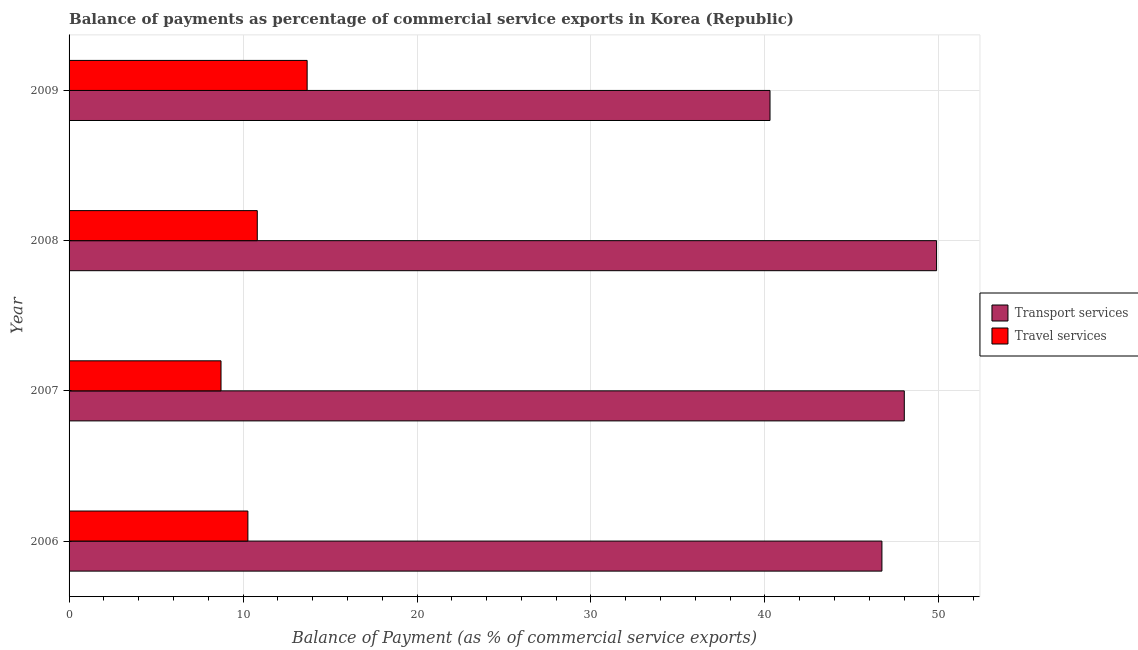How many different coloured bars are there?
Offer a terse response. 2. How many groups of bars are there?
Your response must be concise. 4. How many bars are there on the 1st tick from the bottom?
Make the answer very short. 2. What is the balance of payments of transport services in 2007?
Keep it short and to the point. 48.01. Across all years, what is the maximum balance of payments of transport services?
Keep it short and to the point. 49.86. Across all years, what is the minimum balance of payments of transport services?
Ensure brevity in your answer.  40.29. In which year was the balance of payments of transport services minimum?
Provide a short and direct response. 2009. What is the total balance of payments of travel services in the graph?
Keep it short and to the point. 43.52. What is the difference between the balance of payments of transport services in 2008 and that in 2009?
Keep it short and to the point. 9.57. What is the difference between the balance of payments of transport services in 2008 and the balance of payments of travel services in 2009?
Your response must be concise. 36.18. What is the average balance of payments of travel services per year?
Give a very brief answer. 10.88. In the year 2007, what is the difference between the balance of payments of transport services and balance of payments of travel services?
Keep it short and to the point. 39.28. What is the ratio of the balance of payments of travel services in 2008 to that in 2009?
Keep it short and to the point. 0.79. What is the difference between the highest and the second highest balance of payments of transport services?
Your answer should be compact. 1.85. What is the difference between the highest and the lowest balance of payments of travel services?
Make the answer very short. 4.95. Is the sum of the balance of payments of transport services in 2006 and 2008 greater than the maximum balance of payments of travel services across all years?
Make the answer very short. Yes. What does the 1st bar from the top in 2007 represents?
Your answer should be compact. Travel services. What does the 2nd bar from the bottom in 2007 represents?
Your response must be concise. Travel services. How many bars are there?
Provide a succinct answer. 8. Are all the bars in the graph horizontal?
Your answer should be compact. Yes. What is the difference between two consecutive major ticks on the X-axis?
Make the answer very short. 10. Are the values on the major ticks of X-axis written in scientific E-notation?
Offer a very short reply. No. Where does the legend appear in the graph?
Your response must be concise. Center right. How many legend labels are there?
Ensure brevity in your answer.  2. How are the legend labels stacked?
Offer a terse response. Vertical. What is the title of the graph?
Ensure brevity in your answer.  Balance of payments as percentage of commercial service exports in Korea (Republic). Does "Current US$" appear as one of the legend labels in the graph?
Your answer should be very brief. No. What is the label or title of the X-axis?
Provide a succinct answer. Balance of Payment (as % of commercial service exports). What is the Balance of Payment (as % of commercial service exports) in Transport services in 2006?
Your answer should be very brief. 46.72. What is the Balance of Payment (as % of commercial service exports) in Travel services in 2006?
Your response must be concise. 10.28. What is the Balance of Payment (as % of commercial service exports) of Transport services in 2007?
Offer a very short reply. 48.01. What is the Balance of Payment (as % of commercial service exports) in Travel services in 2007?
Make the answer very short. 8.73. What is the Balance of Payment (as % of commercial service exports) in Transport services in 2008?
Provide a short and direct response. 49.86. What is the Balance of Payment (as % of commercial service exports) of Travel services in 2008?
Keep it short and to the point. 10.82. What is the Balance of Payment (as % of commercial service exports) of Transport services in 2009?
Provide a short and direct response. 40.29. What is the Balance of Payment (as % of commercial service exports) in Travel services in 2009?
Your response must be concise. 13.68. Across all years, what is the maximum Balance of Payment (as % of commercial service exports) in Transport services?
Give a very brief answer. 49.86. Across all years, what is the maximum Balance of Payment (as % of commercial service exports) of Travel services?
Give a very brief answer. 13.68. Across all years, what is the minimum Balance of Payment (as % of commercial service exports) of Transport services?
Your answer should be very brief. 40.29. Across all years, what is the minimum Balance of Payment (as % of commercial service exports) of Travel services?
Provide a succinct answer. 8.73. What is the total Balance of Payment (as % of commercial service exports) in Transport services in the graph?
Give a very brief answer. 184.89. What is the total Balance of Payment (as % of commercial service exports) of Travel services in the graph?
Offer a very short reply. 43.52. What is the difference between the Balance of Payment (as % of commercial service exports) of Transport services in 2006 and that in 2007?
Your answer should be compact. -1.29. What is the difference between the Balance of Payment (as % of commercial service exports) in Travel services in 2006 and that in 2007?
Make the answer very short. 1.54. What is the difference between the Balance of Payment (as % of commercial service exports) in Transport services in 2006 and that in 2008?
Offer a very short reply. -3.14. What is the difference between the Balance of Payment (as % of commercial service exports) of Travel services in 2006 and that in 2008?
Your answer should be compact. -0.54. What is the difference between the Balance of Payment (as % of commercial service exports) of Transport services in 2006 and that in 2009?
Offer a terse response. 6.43. What is the difference between the Balance of Payment (as % of commercial service exports) in Travel services in 2006 and that in 2009?
Offer a very short reply. -3.41. What is the difference between the Balance of Payment (as % of commercial service exports) of Transport services in 2007 and that in 2008?
Provide a succinct answer. -1.86. What is the difference between the Balance of Payment (as % of commercial service exports) in Travel services in 2007 and that in 2008?
Make the answer very short. -2.08. What is the difference between the Balance of Payment (as % of commercial service exports) of Transport services in 2007 and that in 2009?
Your answer should be very brief. 7.72. What is the difference between the Balance of Payment (as % of commercial service exports) in Travel services in 2007 and that in 2009?
Give a very brief answer. -4.95. What is the difference between the Balance of Payment (as % of commercial service exports) of Transport services in 2008 and that in 2009?
Give a very brief answer. 9.57. What is the difference between the Balance of Payment (as % of commercial service exports) of Travel services in 2008 and that in 2009?
Ensure brevity in your answer.  -2.87. What is the difference between the Balance of Payment (as % of commercial service exports) of Transport services in 2006 and the Balance of Payment (as % of commercial service exports) of Travel services in 2007?
Your response must be concise. 37.99. What is the difference between the Balance of Payment (as % of commercial service exports) of Transport services in 2006 and the Balance of Payment (as % of commercial service exports) of Travel services in 2008?
Provide a succinct answer. 35.91. What is the difference between the Balance of Payment (as % of commercial service exports) in Transport services in 2006 and the Balance of Payment (as % of commercial service exports) in Travel services in 2009?
Provide a succinct answer. 33.04. What is the difference between the Balance of Payment (as % of commercial service exports) in Transport services in 2007 and the Balance of Payment (as % of commercial service exports) in Travel services in 2008?
Offer a very short reply. 37.19. What is the difference between the Balance of Payment (as % of commercial service exports) in Transport services in 2007 and the Balance of Payment (as % of commercial service exports) in Travel services in 2009?
Keep it short and to the point. 34.32. What is the difference between the Balance of Payment (as % of commercial service exports) in Transport services in 2008 and the Balance of Payment (as % of commercial service exports) in Travel services in 2009?
Provide a succinct answer. 36.18. What is the average Balance of Payment (as % of commercial service exports) of Transport services per year?
Your answer should be very brief. 46.22. What is the average Balance of Payment (as % of commercial service exports) in Travel services per year?
Give a very brief answer. 10.88. In the year 2006, what is the difference between the Balance of Payment (as % of commercial service exports) in Transport services and Balance of Payment (as % of commercial service exports) in Travel services?
Give a very brief answer. 36.45. In the year 2007, what is the difference between the Balance of Payment (as % of commercial service exports) in Transport services and Balance of Payment (as % of commercial service exports) in Travel services?
Give a very brief answer. 39.28. In the year 2008, what is the difference between the Balance of Payment (as % of commercial service exports) of Transport services and Balance of Payment (as % of commercial service exports) of Travel services?
Give a very brief answer. 39.05. In the year 2009, what is the difference between the Balance of Payment (as % of commercial service exports) of Transport services and Balance of Payment (as % of commercial service exports) of Travel services?
Keep it short and to the point. 26.61. What is the ratio of the Balance of Payment (as % of commercial service exports) of Transport services in 2006 to that in 2007?
Your answer should be compact. 0.97. What is the ratio of the Balance of Payment (as % of commercial service exports) in Travel services in 2006 to that in 2007?
Keep it short and to the point. 1.18. What is the ratio of the Balance of Payment (as % of commercial service exports) in Transport services in 2006 to that in 2008?
Your response must be concise. 0.94. What is the ratio of the Balance of Payment (as % of commercial service exports) in Travel services in 2006 to that in 2008?
Give a very brief answer. 0.95. What is the ratio of the Balance of Payment (as % of commercial service exports) in Transport services in 2006 to that in 2009?
Keep it short and to the point. 1.16. What is the ratio of the Balance of Payment (as % of commercial service exports) in Travel services in 2006 to that in 2009?
Offer a terse response. 0.75. What is the ratio of the Balance of Payment (as % of commercial service exports) in Transport services in 2007 to that in 2008?
Offer a terse response. 0.96. What is the ratio of the Balance of Payment (as % of commercial service exports) of Travel services in 2007 to that in 2008?
Offer a very short reply. 0.81. What is the ratio of the Balance of Payment (as % of commercial service exports) in Transport services in 2007 to that in 2009?
Your response must be concise. 1.19. What is the ratio of the Balance of Payment (as % of commercial service exports) of Travel services in 2007 to that in 2009?
Ensure brevity in your answer.  0.64. What is the ratio of the Balance of Payment (as % of commercial service exports) in Transport services in 2008 to that in 2009?
Make the answer very short. 1.24. What is the ratio of the Balance of Payment (as % of commercial service exports) in Travel services in 2008 to that in 2009?
Your answer should be compact. 0.79. What is the difference between the highest and the second highest Balance of Payment (as % of commercial service exports) in Transport services?
Offer a very short reply. 1.86. What is the difference between the highest and the second highest Balance of Payment (as % of commercial service exports) in Travel services?
Give a very brief answer. 2.87. What is the difference between the highest and the lowest Balance of Payment (as % of commercial service exports) of Transport services?
Your answer should be compact. 9.57. What is the difference between the highest and the lowest Balance of Payment (as % of commercial service exports) of Travel services?
Provide a short and direct response. 4.95. 